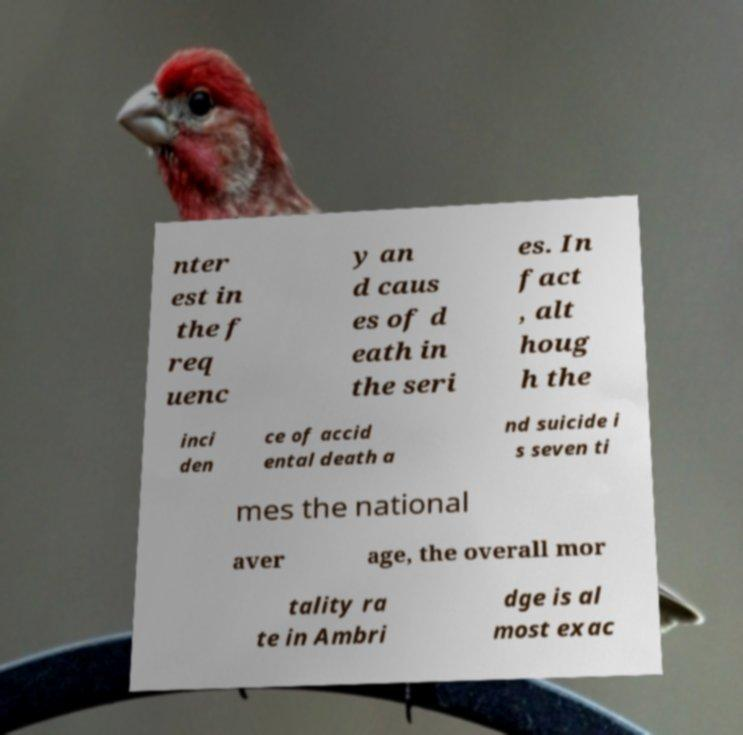Can you read and provide the text displayed in the image?This photo seems to have some interesting text. Can you extract and type it out for me? nter est in the f req uenc y an d caus es of d eath in the seri es. In fact , alt houg h the inci den ce of accid ental death a nd suicide i s seven ti mes the national aver age, the overall mor tality ra te in Ambri dge is al most exac 